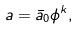<formula> <loc_0><loc_0><loc_500><loc_500>a = \bar { a } _ { 0 } \phi ^ { k } ,</formula> 